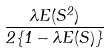<formula> <loc_0><loc_0><loc_500><loc_500>\frac { \lambda E ( S ^ { 2 } ) } { 2 \{ 1 - \lambda E ( S ) \} }</formula> 